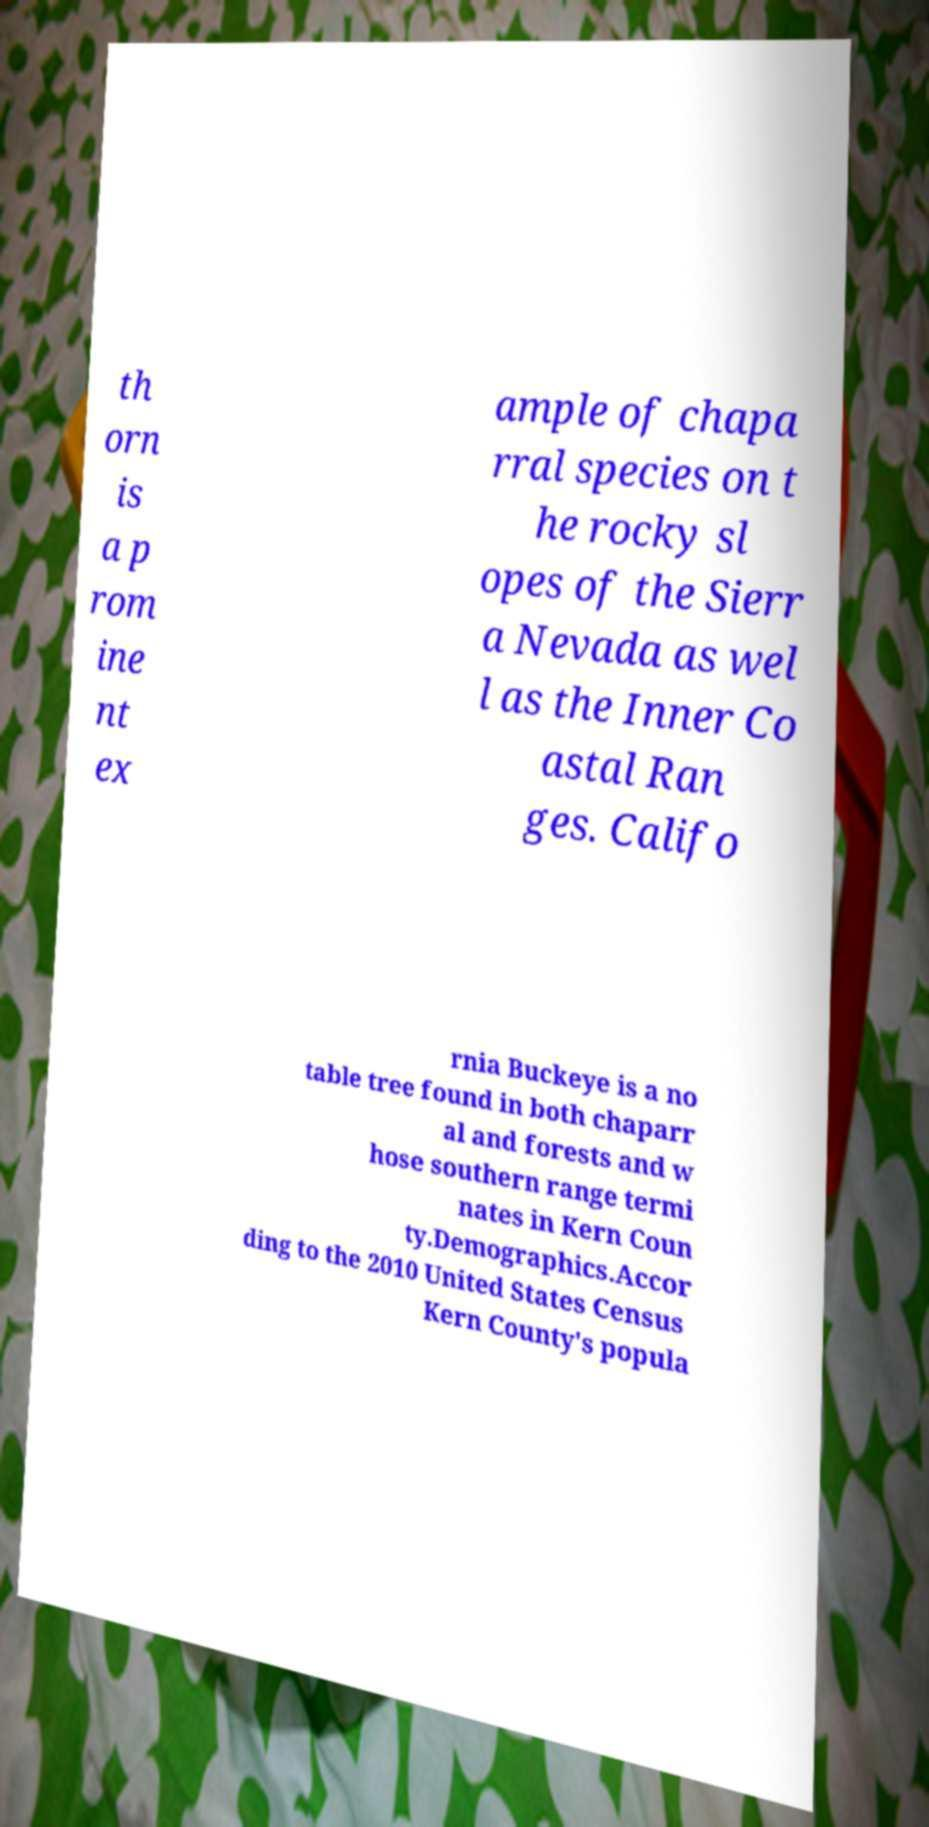Please read and relay the text visible in this image. What does it say? th orn is a p rom ine nt ex ample of chapa rral species on t he rocky sl opes of the Sierr a Nevada as wel l as the Inner Co astal Ran ges. Califo rnia Buckeye is a no table tree found in both chaparr al and forests and w hose southern range termi nates in Kern Coun ty.Demographics.Accor ding to the 2010 United States Census Kern County's popula 